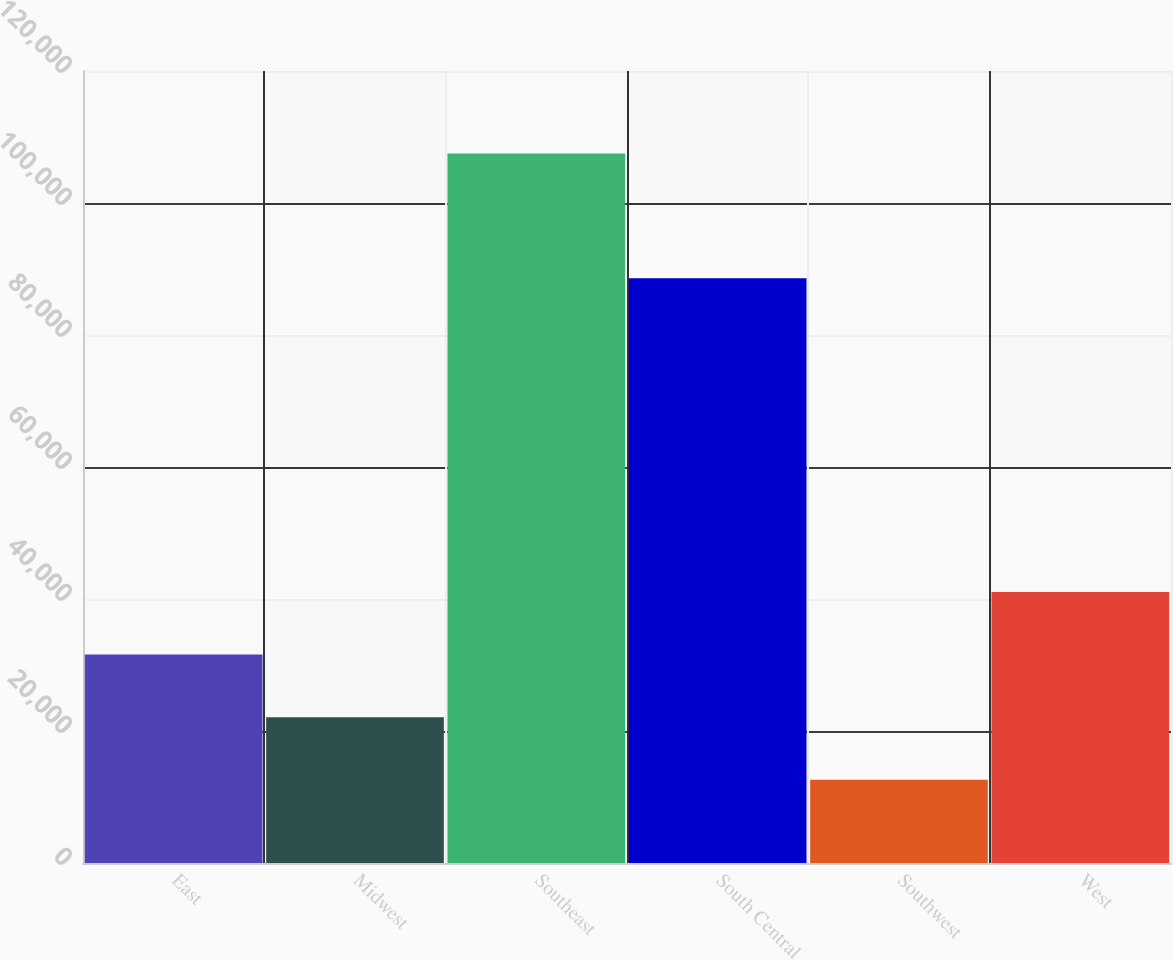<chart> <loc_0><loc_0><loc_500><loc_500><bar_chart><fcel>East<fcel>Midwest<fcel>Southeast<fcel>South Central<fcel>Southwest<fcel>West<nl><fcel>31580<fcel>22090<fcel>107500<fcel>88600<fcel>12600<fcel>41070<nl></chart> 